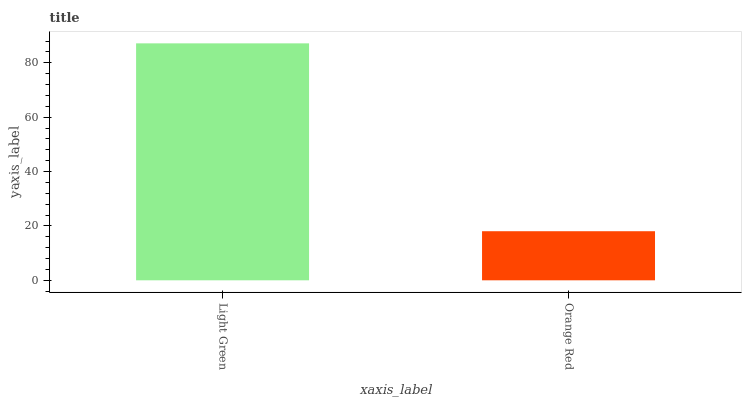Is Orange Red the minimum?
Answer yes or no. Yes. Is Light Green the maximum?
Answer yes or no. Yes. Is Orange Red the maximum?
Answer yes or no. No. Is Light Green greater than Orange Red?
Answer yes or no. Yes. Is Orange Red less than Light Green?
Answer yes or no. Yes. Is Orange Red greater than Light Green?
Answer yes or no. No. Is Light Green less than Orange Red?
Answer yes or no. No. Is Light Green the high median?
Answer yes or no. Yes. Is Orange Red the low median?
Answer yes or no. Yes. Is Orange Red the high median?
Answer yes or no. No. Is Light Green the low median?
Answer yes or no. No. 